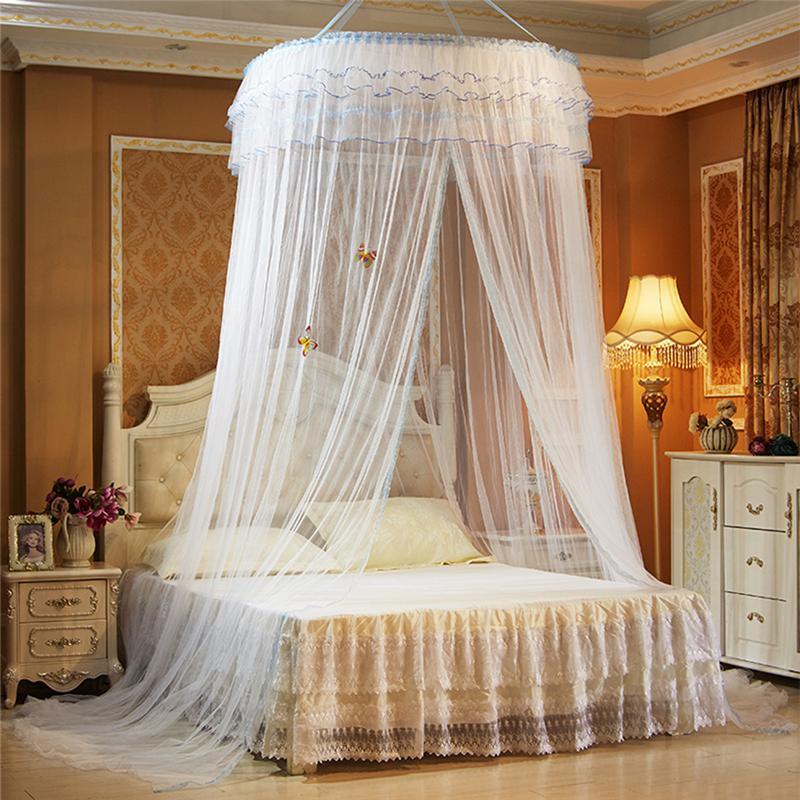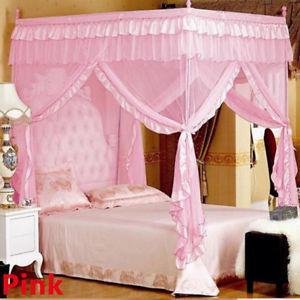The first image is the image on the left, the second image is the image on the right. Assess this claim about the two images: "The netting in the right image is white.". Correct or not? Answer yes or no. No. The first image is the image on the left, the second image is the image on the right. For the images displayed, is the sentence "The right image shows a non-white canopy." factually correct? Answer yes or no. Yes. 